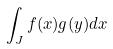Convert formula to latex. <formula><loc_0><loc_0><loc_500><loc_500>\int _ { J } f ( x ) g ( y ) d x</formula> 